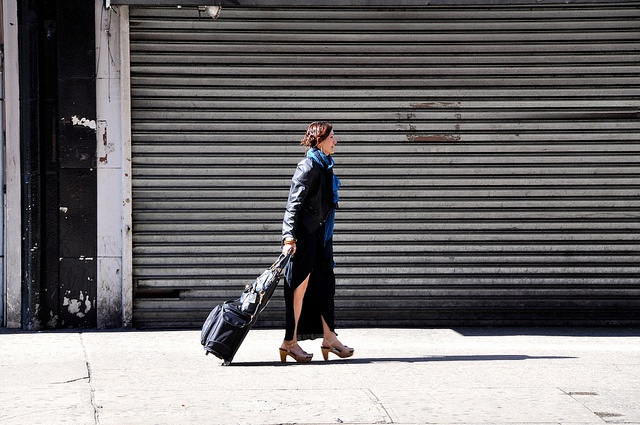Describe the objects in this image and their specific colors. I can see people in gray, black, lavender, and darkgray tones, suitcase in gray, black, lavender, and darkgray tones, backpack in gray, black, white, and darkgray tones, and handbag in gray, white, black, and darkgray tones in this image. 